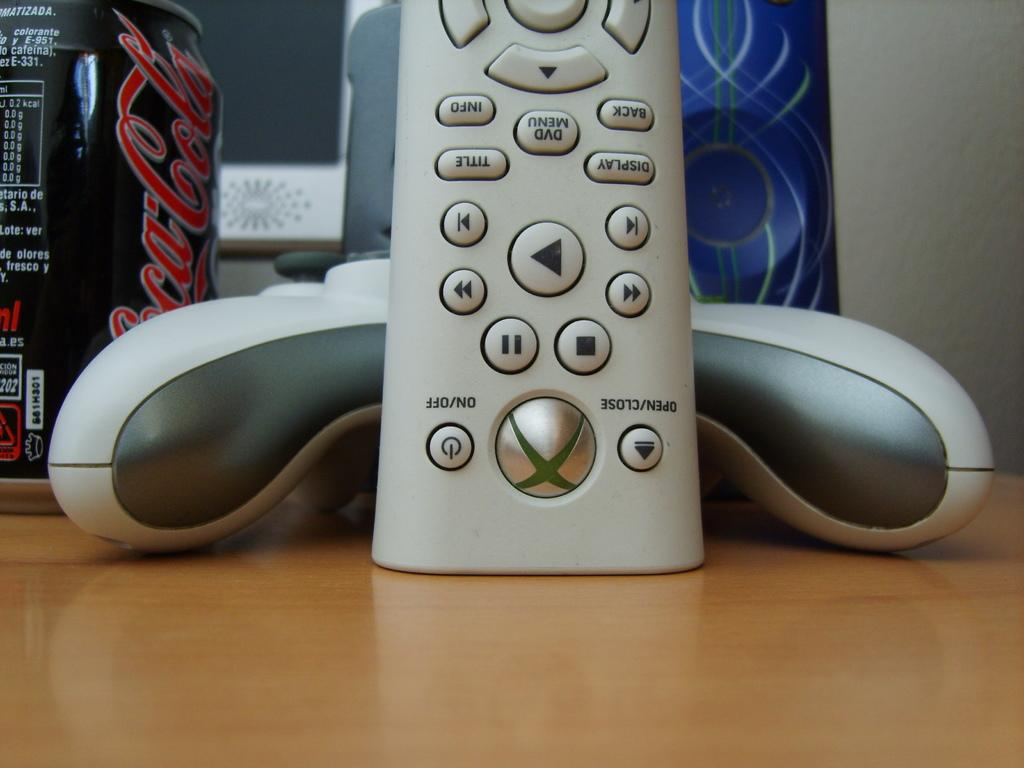<image>
Render a clear and concise summary of the photo. Remote for an xbox with the on and off buttons near the bottom. 